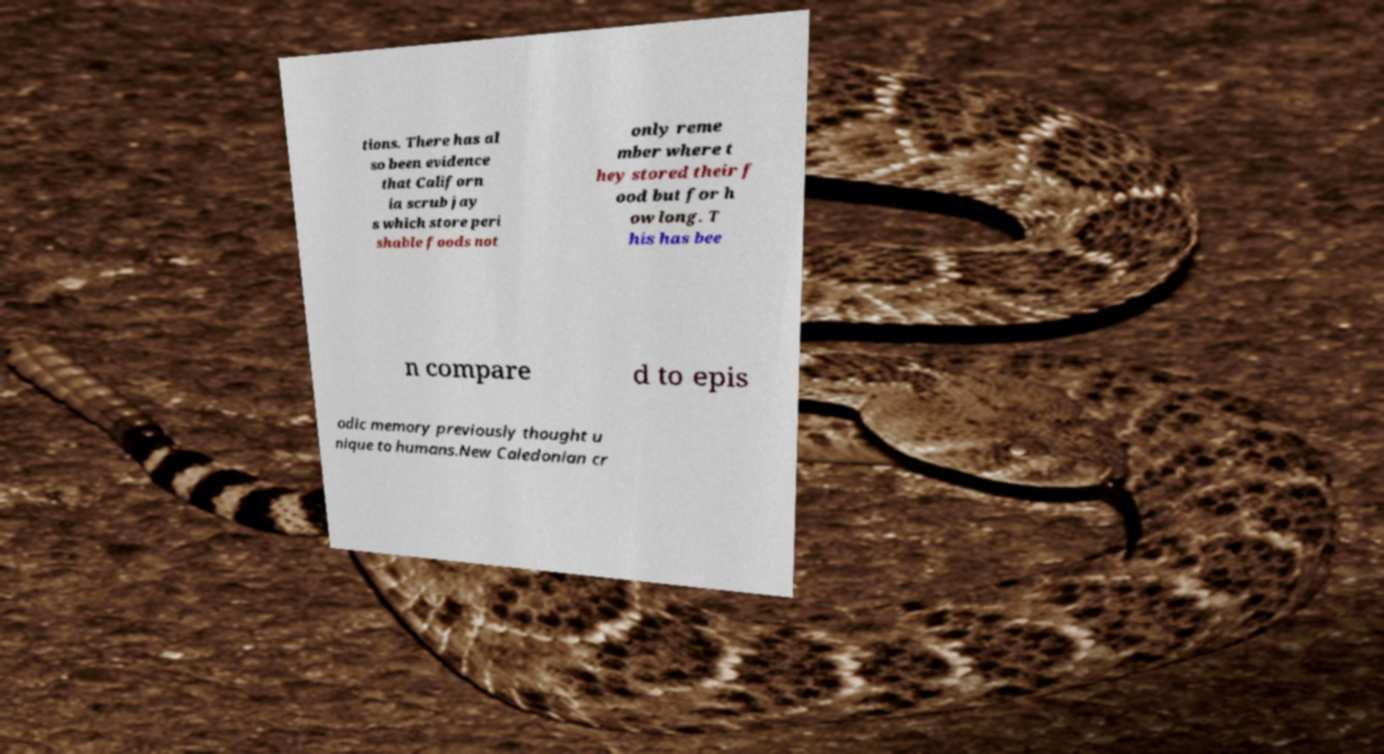What messages or text are displayed in this image? I need them in a readable, typed format. tions. There has al so been evidence that Californ ia scrub jay s which store peri shable foods not only reme mber where t hey stored their f ood but for h ow long. T his has bee n compare d to epis odic memory previously thought u nique to humans.New Caledonian cr 